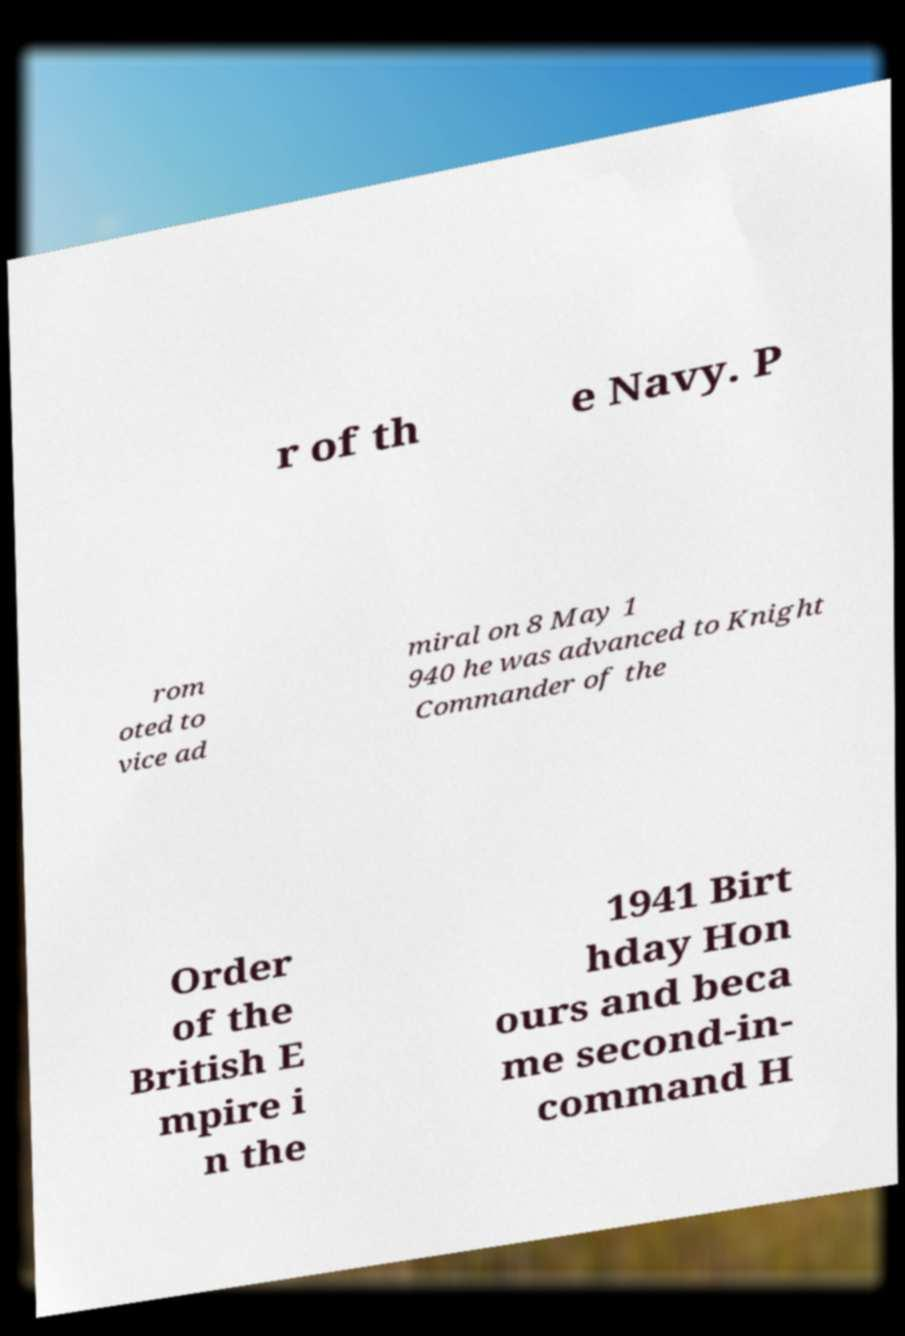Please read and relay the text visible in this image. What does it say? r of th e Navy. P rom oted to vice ad miral on 8 May 1 940 he was advanced to Knight Commander of the Order of the British E mpire i n the 1941 Birt hday Hon ours and beca me second-in- command H 